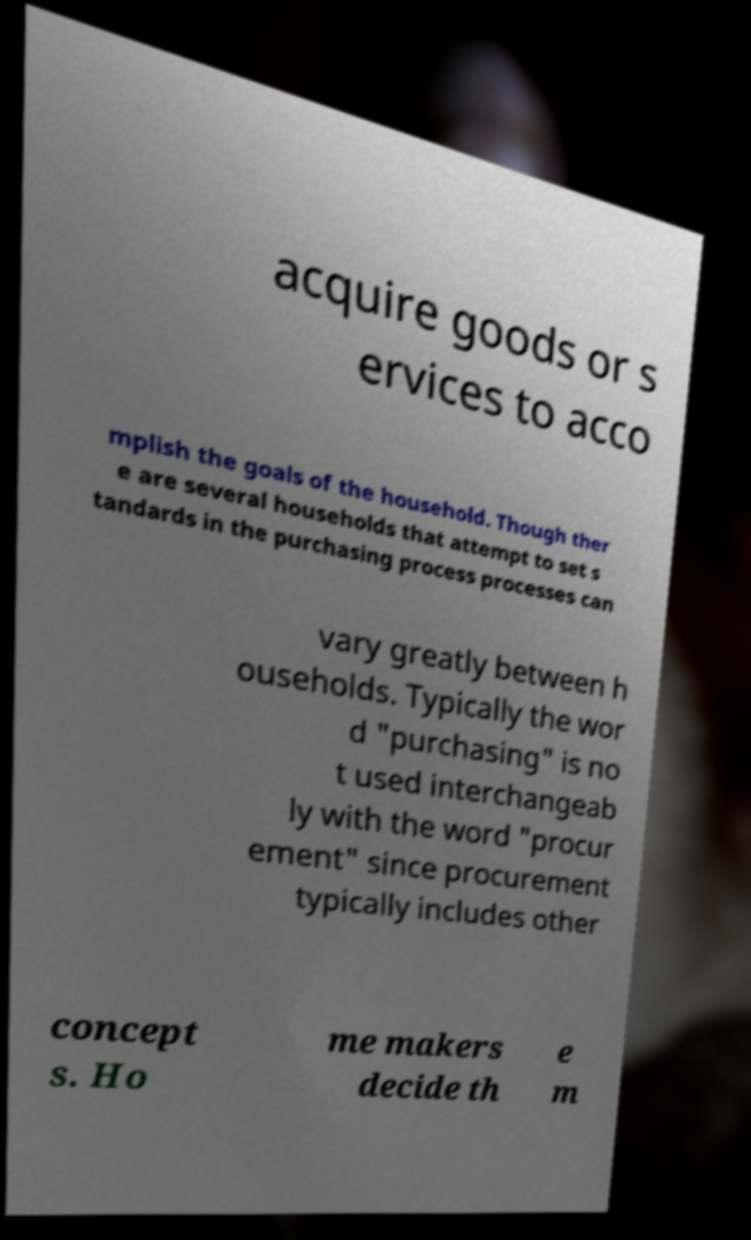There's text embedded in this image that I need extracted. Can you transcribe it verbatim? acquire goods or s ervices to acco mplish the goals of the household. Though ther e are several households that attempt to set s tandards in the purchasing process processes can vary greatly between h ouseholds. Typically the wor d "purchasing" is no t used interchangeab ly with the word "procur ement" since procurement typically includes other concept s. Ho me makers decide th e m 